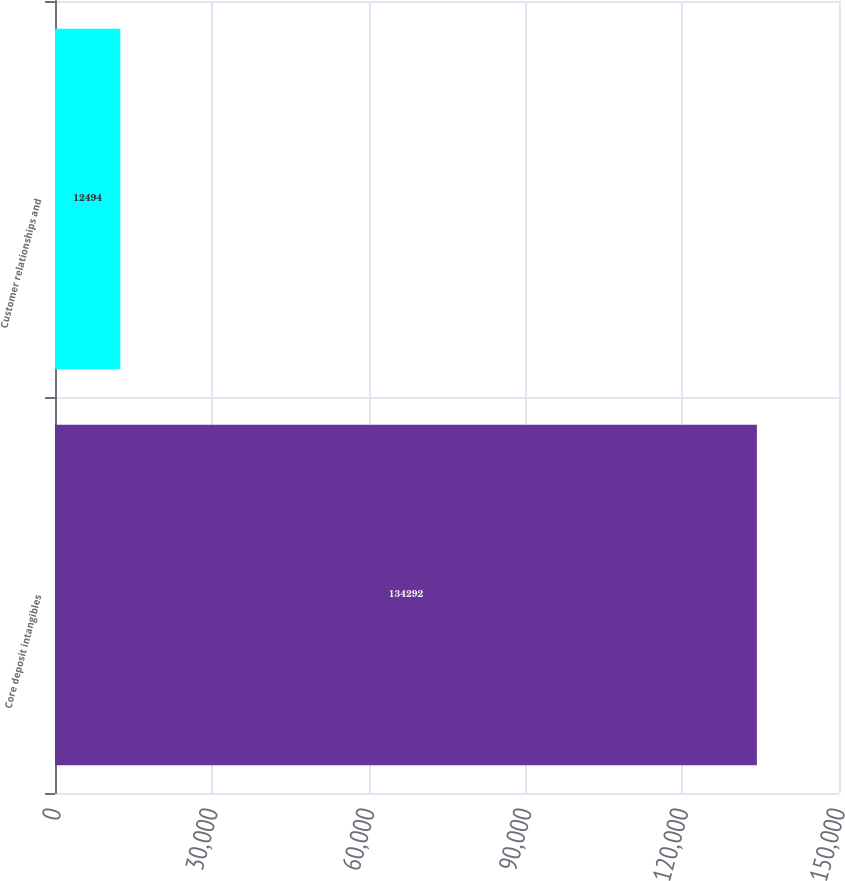<chart> <loc_0><loc_0><loc_500><loc_500><bar_chart><fcel>Core deposit intangibles<fcel>Customer relationships and<nl><fcel>134292<fcel>12494<nl></chart> 